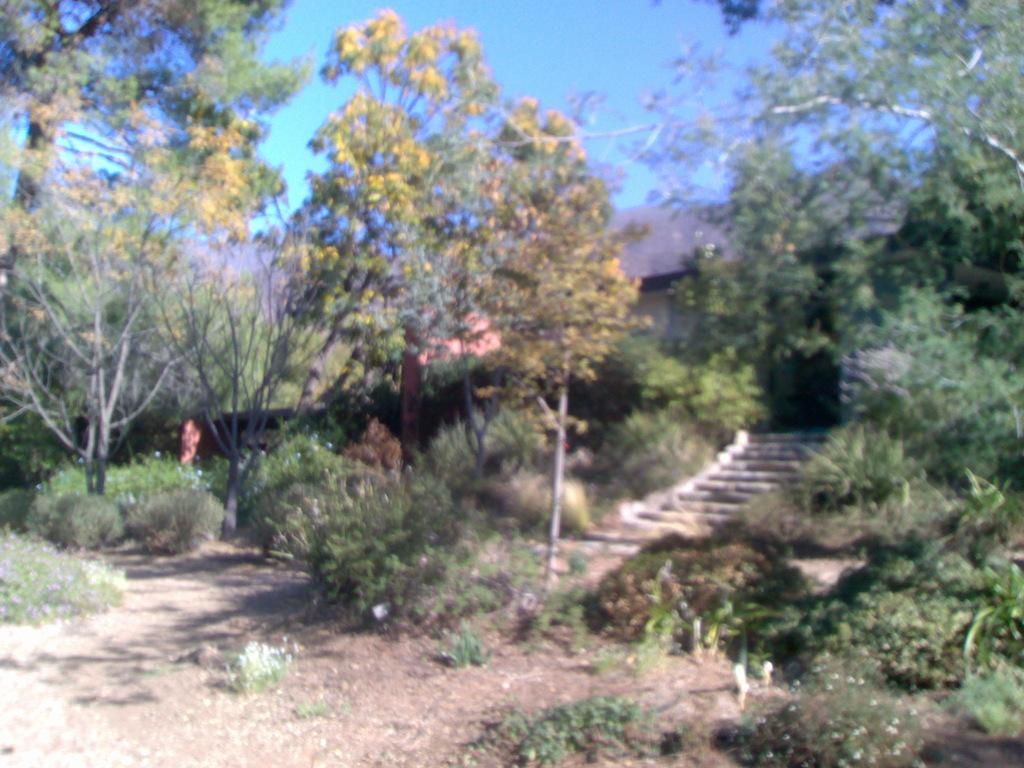What type of vegetation can be seen in the image? There are shrubs and trees in the image. Are there any architectural features present in the image? Yes, there are steps in the image. What type of building is visible in the image? There is a house in the image. What color is the sky in the background of the image? The sky is blue in the background of the image. How does the fog affect the visibility of the shrubs in the image? There is no fog present in the image, so it does not affect the visibility of the shrubs. What type of cabbage is growing near the house in the image? There is no cabbage present in the image. 